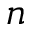<formula> <loc_0><loc_0><loc_500><loc_500>n</formula> 